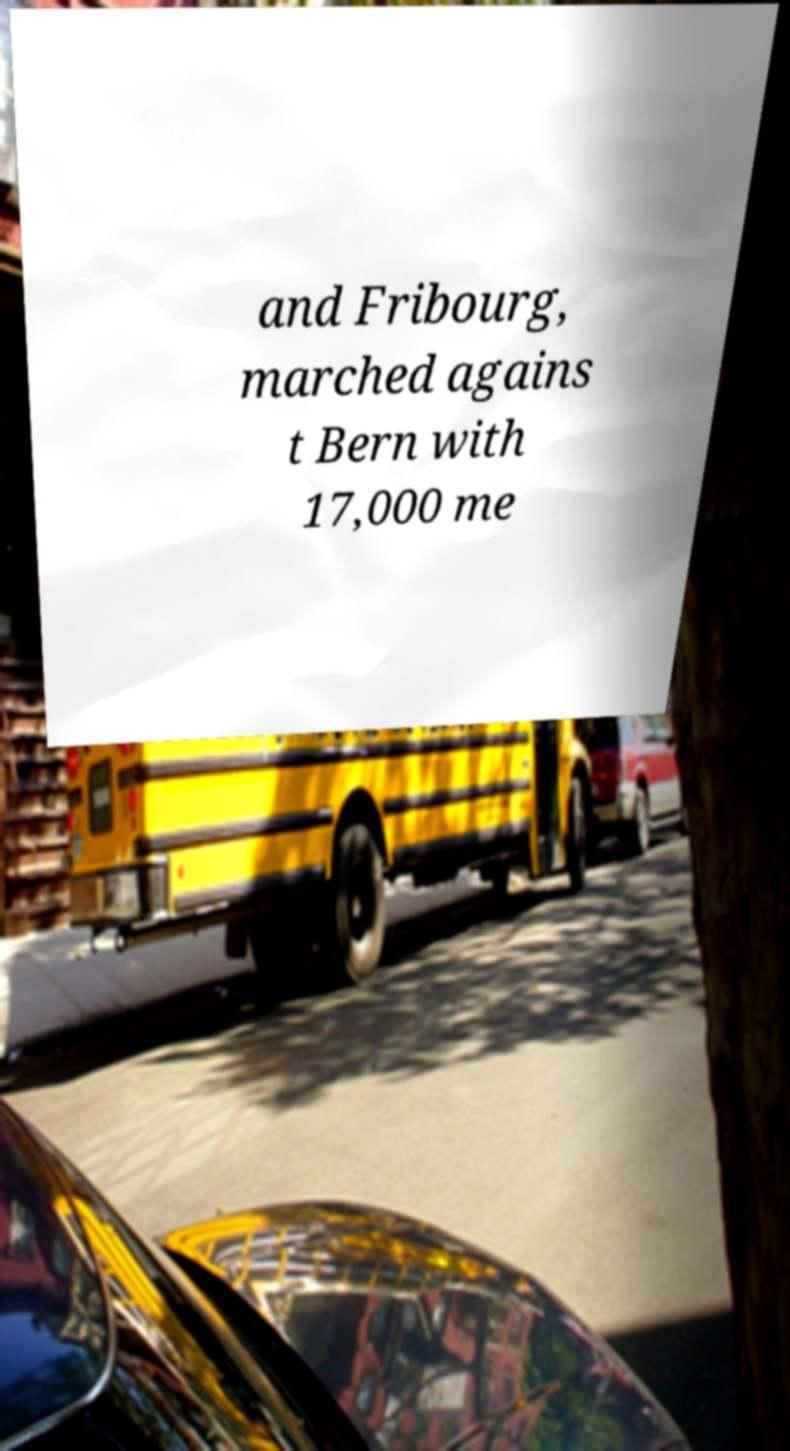Can you read and provide the text displayed in the image?This photo seems to have some interesting text. Can you extract and type it out for me? and Fribourg, marched agains t Bern with 17,000 me 